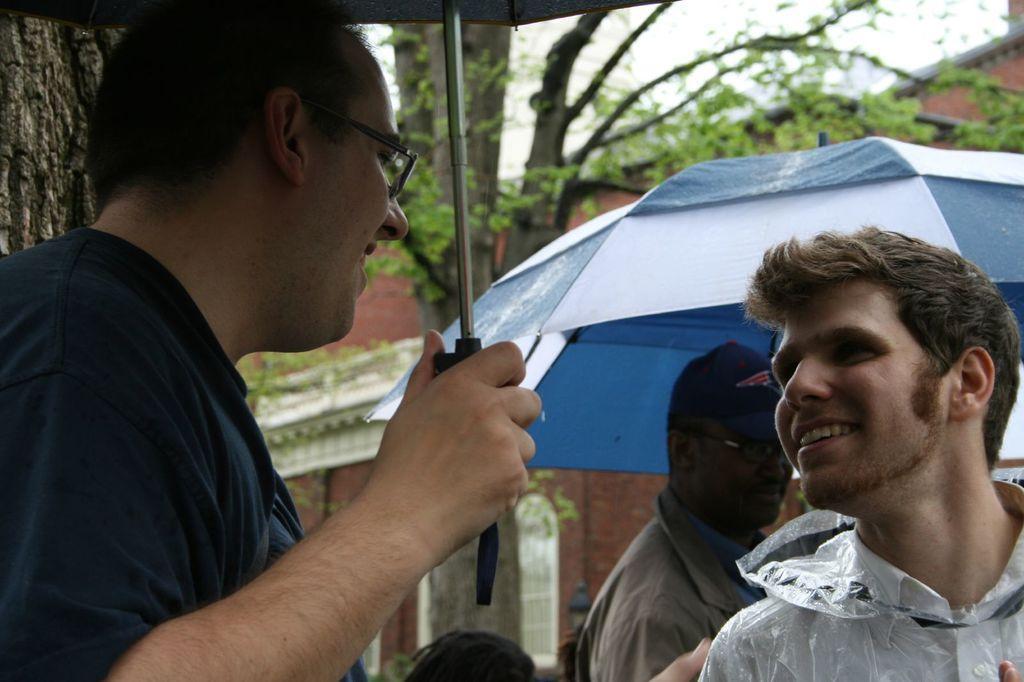How would you summarize this image in a sentence or two? In the center of the image there is a person holding a umbrella. To the right side of the image there is a person wearing a raincoat. In the background of the image there are buildings and trees. There is another person holding a umbrella 